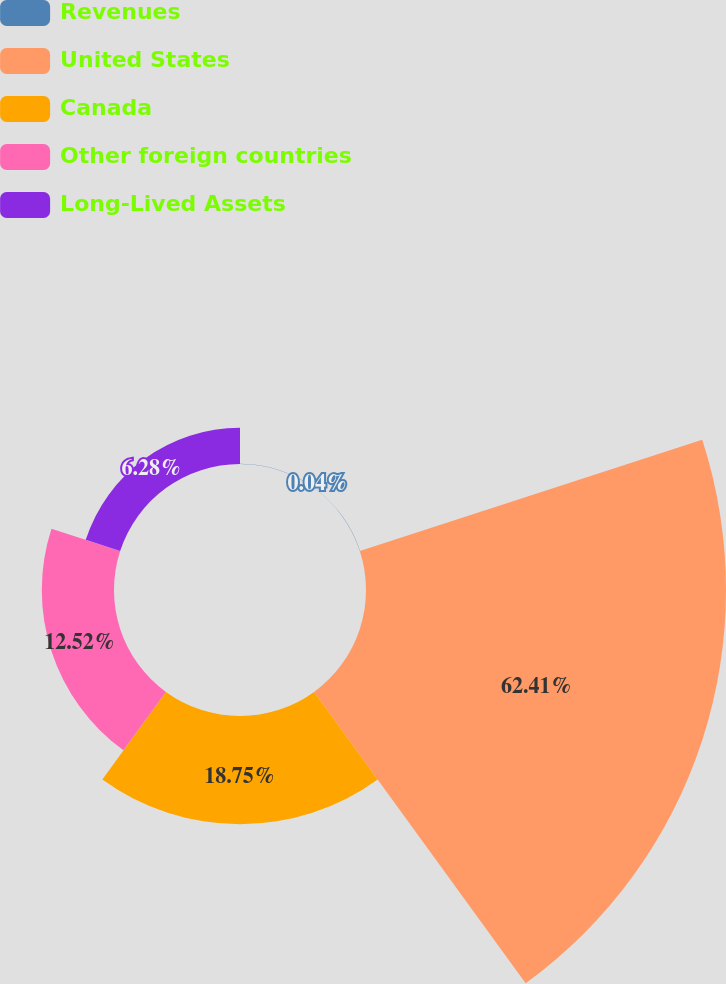<chart> <loc_0><loc_0><loc_500><loc_500><pie_chart><fcel>Revenues<fcel>United States<fcel>Canada<fcel>Other foreign countries<fcel>Long-Lived Assets<nl><fcel>0.04%<fcel>62.41%<fcel>18.75%<fcel>12.52%<fcel>6.28%<nl></chart> 